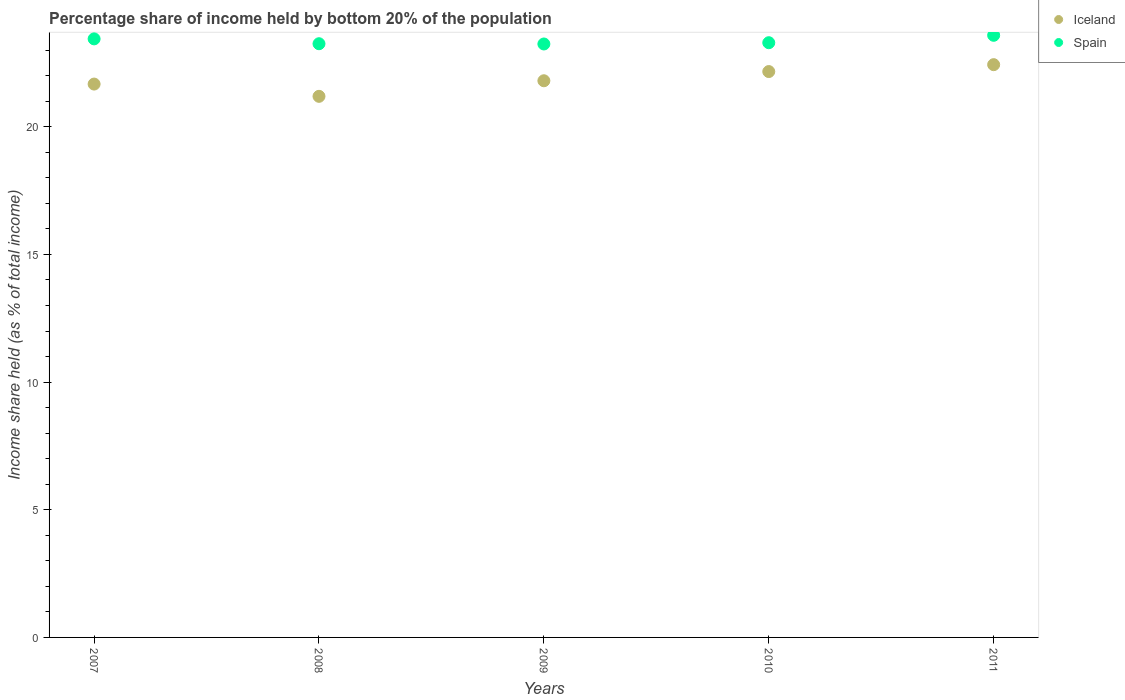How many different coloured dotlines are there?
Give a very brief answer. 2. What is the share of income held by bottom 20% of the population in Spain in 2008?
Offer a terse response. 23.25. Across all years, what is the maximum share of income held by bottom 20% of the population in Iceland?
Keep it short and to the point. 22.43. Across all years, what is the minimum share of income held by bottom 20% of the population in Iceland?
Keep it short and to the point. 21.19. In which year was the share of income held by bottom 20% of the population in Spain maximum?
Give a very brief answer. 2011. In which year was the share of income held by bottom 20% of the population in Spain minimum?
Your answer should be compact. 2009. What is the total share of income held by bottom 20% of the population in Spain in the graph?
Offer a very short reply. 116.8. What is the difference between the share of income held by bottom 20% of the population in Iceland in 2009 and that in 2011?
Ensure brevity in your answer.  -0.63. What is the difference between the share of income held by bottom 20% of the population in Spain in 2007 and the share of income held by bottom 20% of the population in Iceland in 2009?
Keep it short and to the point. 1.64. What is the average share of income held by bottom 20% of the population in Spain per year?
Offer a very short reply. 23.36. In the year 2010, what is the difference between the share of income held by bottom 20% of the population in Spain and share of income held by bottom 20% of the population in Iceland?
Provide a succinct answer. 1.13. In how many years, is the share of income held by bottom 20% of the population in Iceland greater than 11 %?
Your answer should be compact. 5. What is the ratio of the share of income held by bottom 20% of the population in Spain in 2010 to that in 2011?
Provide a short and direct response. 0.99. Is the difference between the share of income held by bottom 20% of the population in Spain in 2007 and 2011 greater than the difference between the share of income held by bottom 20% of the population in Iceland in 2007 and 2011?
Keep it short and to the point. Yes. What is the difference between the highest and the second highest share of income held by bottom 20% of the population in Spain?
Your response must be concise. 0.14. What is the difference between the highest and the lowest share of income held by bottom 20% of the population in Spain?
Your answer should be compact. 0.34. Is the sum of the share of income held by bottom 20% of the population in Spain in 2009 and 2010 greater than the maximum share of income held by bottom 20% of the population in Iceland across all years?
Your response must be concise. Yes. Does the share of income held by bottom 20% of the population in Iceland monotonically increase over the years?
Provide a short and direct response. No. How many dotlines are there?
Your answer should be very brief. 2. Are the values on the major ticks of Y-axis written in scientific E-notation?
Keep it short and to the point. No. Does the graph contain any zero values?
Ensure brevity in your answer.  No. Where does the legend appear in the graph?
Provide a succinct answer. Top right. How are the legend labels stacked?
Your answer should be very brief. Vertical. What is the title of the graph?
Your response must be concise. Percentage share of income held by bottom 20% of the population. What is the label or title of the X-axis?
Keep it short and to the point. Years. What is the label or title of the Y-axis?
Provide a succinct answer. Income share held (as % of total income). What is the Income share held (as % of total income) of Iceland in 2007?
Provide a short and direct response. 21.67. What is the Income share held (as % of total income) in Spain in 2007?
Offer a very short reply. 23.44. What is the Income share held (as % of total income) in Iceland in 2008?
Keep it short and to the point. 21.19. What is the Income share held (as % of total income) in Spain in 2008?
Give a very brief answer. 23.25. What is the Income share held (as % of total income) of Iceland in 2009?
Offer a terse response. 21.8. What is the Income share held (as % of total income) in Spain in 2009?
Provide a short and direct response. 23.24. What is the Income share held (as % of total income) in Iceland in 2010?
Ensure brevity in your answer.  22.16. What is the Income share held (as % of total income) of Spain in 2010?
Offer a terse response. 23.29. What is the Income share held (as % of total income) in Iceland in 2011?
Your response must be concise. 22.43. What is the Income share held (as % of total income) in Spain in 2011?
Offer a terse response. 23.58. Across all years, what is the maximum Income share held (as % of total income) in Iceland?
Give a very brief answer. 22.43. Across all years, what is the maximum Income share held (as % of total income) of Spain?
Offer a very short reply. 23.58. Across all years, what is the minimum Income share held (as % of total income) in Iceland?
Provide a succinct answer. 21.19. Across all years, what is the minimum Income share held (as % of total income) of Spain?
Your response must be concise. 23.24. What is the total Income share held (as % of total income) of Iceland in the graph?
Give a very brief answer. 109.25. What is the total Income share held (as % of total income) of Spain in the graph?
Keep it short and to the point. 116.8. What is the difference between the Income share held (as % of total income) of Iceland in 2007 and that in 2008?
Your answer should be compact. 0.48. What is the difference between the Income share held (as % of total income) of Spain in 2007 and that in 2008?
Your response must be concise. 0.19. What is the difference between the Income share held (as % of total income) in Iceland in 2007 and that in 2009?
Your answer should be compact. -0.13. What is the difference between the Income share held (as % of total income) of Spain in 2007 and that in 2009?
Offer a very short reply. 0.2. What is the difference between the Income share held (as % of total income) in Iceland in 2007 and that in 2010?
Make the answer very short. -0.49. What is the difference between the Income share held (as % of total income) of Iceland in 2007 and that in 2011?
Provide a short and direct response. -0.76. What is the difference between the Income share held (as % of total income) in Spain in 2007 and that in 2011?
Your response must be concise. -0.14. What is the difference between the Income share held (as % of total income) of Iceland in 2008 and that in 2009?
Ensure brevity in your answer.  -0.61. What is the difference between the Income share held (as % of total income) of Spain in 2008 and that in 2009?
Give a very brief answer. 0.01. What is the difference between the Income share held (as % of total income) of Iceland in 2008 and that in 2010?
Your response must be concise. -0.97. What is the difference between the Income share held (as % of total income) in Spain in 2008 and that in 2010?
Offer a terse response. -0.04. What is the difference between the Income share held (as % of total income) of Iceland in 2008 and that in 2011?
Provide a succinct answer. -1.24. What is the difference between the Income share held (as % of total income) in Spain in 2008 and that in 2011?
Provide a short and direct response. -0.33. What is the difference between the Income share held (as % of total income) of Iceland in 2009 and that in 2010?
Offer a terse response. -0.36. What is the difference between the Income share held (as % of total income) in Iceland in 2009 and that in 2011?
Give a very brief answer. -0.63. What is the difference between the Income share held (as % of total income) in Spain in 2009 and that in 2011?
Your response must be concise. -0.34. What is the difference between the Income share held (as % of total income) in Iceland in 2010 and that in 2011?
Offer a terse response. -0.27. What is the difference between the Income share held (as % of total income) in Spain in 2010 and that in 2011?
Give a very brief answer. -0.29. What is the difference between the Income share held (as % of total income) in Iceland in 2007 and the Income share held (as % of total income) in Spain in 2008?
Your answer should be very brief. -1.58. What is the difference between the Income share held (as % of total income) in Iceland in 2007 and the Income share held (as % of total income) in Spain in 2009?
Your response must be concise. -1.57. What is the difference between the Income share held (as % of total income) in Iceland in 2007 and the Income share held (as % of total income) in Spain in 2010?
Make the answer very short. -1.62. What is the difference between the Income share held (as % of total income) of Iceland in 2007 and the Income share held (as % of total income) of Spain in 2011?
Provide a succinct answer. -1.91. What is the difference between the Income share held (as % of total income) in Iceland in 2008 and the Income share held (as % of total income) in Spain in 2009?
Your response must be concise. -2.05. What is the difference between the Income share held (as % of total income) in Iceland in 2008 and the Income share held (as % of total income) in Spain in 2011?
Ensure brevity in your answer.  -2.39. What is the difference between the Income share held (as % of total income) in Iceland in 2009 and the Income share held (as % of total income) in Spain in 2010?
Your answer should be very brief. -1.49. What is the difference between the Income share held (as % of total income) of Iceland in 2009 and the Income share held (as % of total income) of Spain in 2011?
Provide a succinct answer. -1.78. What is the difference between the Income share held (as % of total income) in Iceland in 2010 and the Income share held (as % of total income) in Spain in 2011?
Provide a succinct answer. -1.42. What is the average Income share held (as % of total income) in Iceland per year?
Your answer should be compact. 21.85. What is the average Income share held (as % of total income) in Spain per year?
Provide a succinct answer. 23.36. In the year 2007, what is the difference between the Income share held (as % of total income) of Iceland and Income share held (as % of total income) of Spain?
Keep it short and to the point. -1.77. In the year 2008, what is the difference between the Income share held (as % of total income) of Iceland and Income share held (as % of total income) of Spain?
Offer a terse response. -2.06. In the year 2009, what is the difference between the Income share held (as % of total income) in Iceland and Income share held (as % of total income) in Spain?
Your answer should be compact. -1.44. In the year 2010, what is the difference between the Income share held (as % of total income) of Iceland and Income share held (as % of total income) of Spain?
Offer a very short reply. -1.13. In the year 2011, what is the difference between the Income share held (as % of total income) of Iceland and Income share held (as % of total income) of Spain?
Give a very brief answer. -1.15. What is the ratio of the Income share held (as % of total income) in Iceland in 2007 to that in 2008?
Provide a short and direct response. 1.02. What is the ratio of the Income share held (as % of total income) of Spain in 2007 to that in 2008?
Give a very brief answer. 1.01. What is the ratio of the Income share held (as % of total income) in Iceland in 2007 to that in 2009?
Your response must be concise. 0.99. What is the ratio of the Income share held (as % of total income) in Spain in 2007 to that in 2009?
Provide a succinct answer. 1.01. What is the ratio of the Income share held (as % of total income) of Iceland in 2007 to that in 2010?
Give a very brief answer. 0.98. What is the ratio of the Income share held (as % of total income) in Spain in 2007 to that in 2010?
Provide a succinct answer. 1.01. What is the ratio of the Income share held (as % of total income) in Iceland in 2007 to that in 2011?
Provide a succinct answer. 0.97. What is the ratio of the Income share held (as % of total income) of Iceland in 2008 to that in 2009?
Make the answer very short. 0.97. What is the ratio of the Income share held (as % of total income) of Iceland in 2008 to that in 2010?
Give a very brief answer. 0.96. What is the ratio of the Income share held (as % of total income) in Iceland in 2008 to that in 2011?
Your response must be concise. 0.94. What is the ratio of the Income share held (as % of total income) in Spain in 2008 to that in 2011?
Provide a succinct answer. 0.99. What is the ratio of the Income share held (as % of total income) of Iceland in 2009 to that in 2010?
Offer a terse response. 0.98. What is the ratio of the Income share held (as % of total income) in Spain in 2009 to that in 2010?
Give a very brief answer. 1. What is the ratio of the Income share held (as % of total income) of Iceland in 2009 to that in 2011?
Provide a succinct answer. 0.97. What is the ratio of the Income share held (as % of total income) in Spain in 2009 to that in 2011?
Offer a very short reply. 0.99. What is the difference between the highest and the second highest Income share held (as % of total income) of Iceland?
Ensure brevity in your answer.  0.27. What is the difference between the highest and the second highest Income share held (as % of total income) in Spain?
Ensure brevity in your answer.  0.14. What is the difference between the highest and the lowest Income share held (as % of total income) of Iceland?
Your answer should be very brief. 1.24. What is the difference between the highest and the lowest Income share held (as % of total income) in Spain?
Keep it short and to the point. 0.34. 